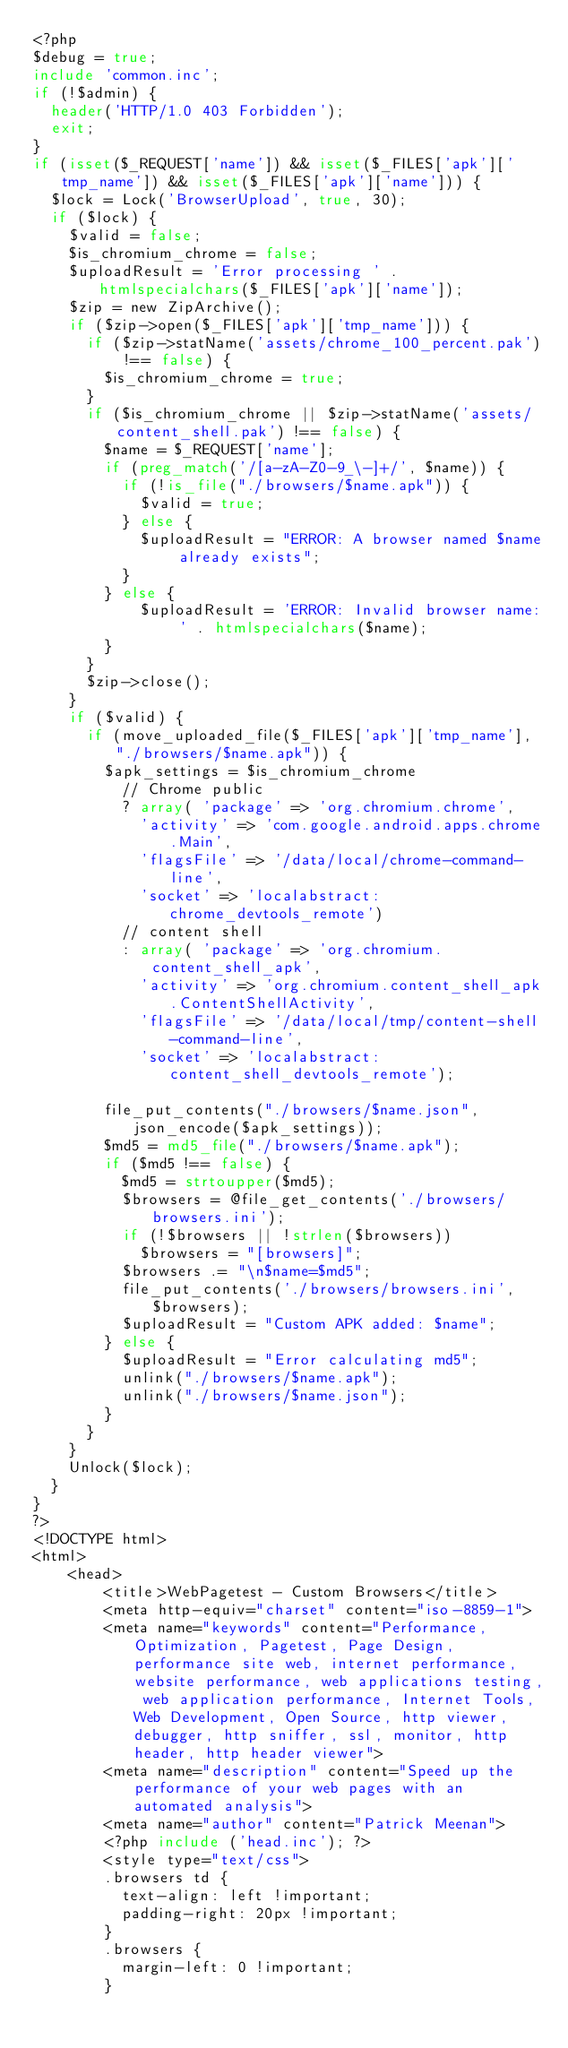<code> <loc_0><loc_0><loc_500><loc_500><_PHP_><?php
$debug = true;
include 'common.inc';
if (!$admin) {
  header('HTTP/1.0 403 Forbidden');
  exit;
}
if (isset($_REQUEST['name']) && isset($_FILES['apk']['tmp_name']) && isset($_FILES['apk']['name'])) {
  $lock = Lock('BrowserUpload', true, 30);
  if ($lock) {
    $valid = false;
    $is_chromium_chrome = false;
    $uploadResult = 'Error processing ' . htmlspecialchars($_FILES['apk']['name']);
    $zip = new ZipArchive();
    if ($zip->open($_FILES['apk']['tmp_name'])) {
      if ($zip->statName('assets/chrome_100_percent.pak') !== false) {
        $is_chromium_chrome = true;
      }
      if ($is_chromium_chrome || $zip->statName('assets/content_shell.pak') !== false) {
        $name = $_REQUEST['name'];
        if (preg_match('/[a-zA-Z0-9_\-]+/', $name)) {
          if (!is_file("./browsers/$name.apk")) {
            $valid = true;
          } else {
            $uploadResult = "ERROR: A browser named $name already exists";
          }
        } else {
            $uploadResult = 'ERROR: Invalid browser name: ' . htmlspecialchars($name);
        }
      }
      $zip->close();
    }
    if ($valid) {
      if (move_uploaded_file($_FILES['apk']['tmp_name'], "./browsers/$name.apk")) {
        $apk_settings = $is_chromium_chrome
          // Chrome public
          ? array( 'package' => 'org.chromium.chrome',
            'activity' => 'com.google.android.apps.chrome.Main',
            'flagsFile' => '/data/local/chrome-command-line',
            'socket' => 'localabstract:chrome_devtools_remote')
          // content shell
          : array( 'package' => 'org.chromium.content_shell_apk',
            'activity' => 'org.chromium.content_shell_apk.ContentShellActivity',
            'flagsFile' => '/data/local/tmp/content-shell-command-line',
            'socket' => 'localabstract:content_shell_devtools_remote');
            
        file_put_contents("./browsers/$name.json", json_encode($apk_settings));
        $md5 = md5_file("./browsers/$name.apk");
        if ($md5 !== false) {
          $md5 = strtoupper($md5);
          $browsers = @file_get_contents('./browsers/browsers.ini');
          if (!$browsers || !strlen($browsers))
            $browsers = "[browsers]";
          $browsers .= "\n$name=$md5";
          file_put_contents('./browsers/browsers.ini', $browsers);
          $uploadResult = "Custom APK added: $name";
        } else {
          $uploadResult = "Error calculating md5";
          unlink("./browsers/$name.apk");
          unlink("./browsers/$name.json");
        }
      }
    }
    Unlock($lock);
  }
}
?>
<!DOCTYPE html>
<html>
    <head>
        <title>WebPagetest - Custom Browsers</title>
        <meta http-equiv="charset" content="iso-8859-1">
        <meta name="keywords" content="Performance, Optimization, Pagetest, Page Design, performance site web, internet performance, website performance, web applications testing, web application performance, Internet Tools, Web Development, Open Source, http viewer, debugger, http sniffer, ssl, monitor, http header, http header viewer">
        <meta name="description" content="Speed up the performance of your web pages with an automated analysis">
        <meta name="author" content="Patrick Meenan">
        <?php include ('head.inc'); ?>
        <style type="text/css">
        .browsers td {
          text-align: left !important;
          padding-right: 20px !important;
        }
        .browsers {
          margin-left: 0 !important;
        }</code> 